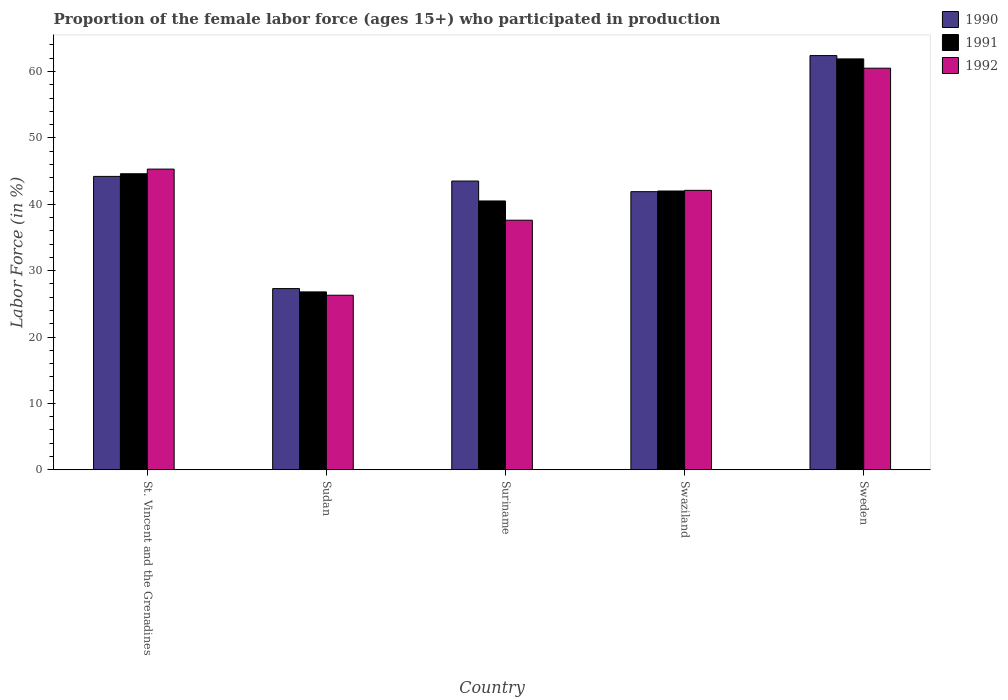How many groups of bars are there?
Provide a succinct answer. 5. Are the number of bars per tick equal to the number of legend labels?
Keep it short and to the point. Yes. How many bars are there on the 2nd tick from the left?
Give a very brief answer. 3. What is the label of the 4th group of bars from the left?
Keep it short and to the point. Swaziland. In how many cases, is the number of bars for a given country not equal to the number of legend labels?
Provide a succinct answer. 0. What is the proportion of the female labor force who participated in production in 1990 in Sudan?
Offer a very short reply. 27.3. Across all countries, what is the maximum proportion of the female labor force who participated in production in 1991?
Keep it short and to the point. 61.9. Across all countries, what is the minimum proportion of the female labor force who participated in production in 1992?
Make the answer very short. 26.3. In which country was the proportion of the female labor force who participated in production in 1991 minimum?
Your response must be concise. Sudan. What is the total proportion of the female labor force who participated in production in 1991 in the graph?
Your answer should be very brief. 215.8. What is the difference between the proportion of the female labor force who participated in production in 1990 in Sudan and that in Suriname?
Keep it short and to the point. -16.2. What is the difference between the proportion of the female labor force who participated in production in 1992 in Sweden and the proportion of the female labor force who participated in production in 1990 in Swaziland?
Provide a succinct answer. 18.6. What is the average proportion of the female labor force who participated in production in 1991 per country?
Keep it short and to the point. 43.16. What is the difference between the proportion of the female labor force who participated in production of/in 1990 and proportion of the female labor force who participated in production of/in 1992 in Swaziland?
Give a very brief answer. -0.2. In how many countries, is the proportion of the female labor force who participated in production in 1990 greater than 52 %?
Provide a short and direct response. 1. What is the ratio of the proportion of the female labor force who participated in production in 1992 in St. Vincent and the Grenadines to that in Sudan?
Provide a succinct answer. 1.72. What is the difference between the highest and the second highest proportion of the female labor force who participated in production in 1991?
Offer a very short reply. -2.6. What is the difference between the highest and the lowest proportion of the female labor force who participated in production in 1992?
Keep it short and to the point. 34.2. In how many countries, is the proportion of the female labor force who participated in production in 1992 greater than the average proportion of the female labor force who participated in production in 1992 taken over all countries?
Make the answer very short. 2. What does the 3rd bar from the left in Swaziland represents?
Offer a terse response. 1992. What does the 1st bar from the right in St. Vincent and the Grenadines represents?
Offer a terse response. 1992. What is the difference between two consecutive major ticks on the Y-axis?
Provide a short and direct response. 10. Are the values on the major ticks of Y-axis written in scientific E-notation?
Keep it short and to the point. No. Does the graph contain any zero values?
Your answer should be compact. No. Does the graph contain grids?
Keep it short and to the point. No. Where does the legend appear in the graph?
Give a very brief answer. Top right. How many legend labels are there?
Give a very brief answer. 3. How are the legend labels stacked?
Ensure brevity in your answer.  Vertical. What is the title of the graph?
Your answer should be very brief. Proportion of the female labor force (ages 15+) who participated in production. What is the Labor Force (in %) of 1990 in St. Vincent and the Grenadines?
Give a very brief answer. 44.2. What is the Labor Force (in %) of 1991 in St. Vincent and the Grenadines?
Provide a succinct answer. 44.6. What is the Labor Force (in %) of 1992 in St. Vincent and the Grenadines?
Keep it short and to the point. 45.3. What is the Labor Force (in %) in 1990 in Sudan?
Your answer should be compact. 27.3. What is the Labor Force (in %) of 1991 in Sudan?
Ensure brevity in your answer.  26.8. What is the Labor Force (in %) in 1992 in Sudan?
Ensure brevity in your answer.  26.3. What is the Labor Force (in %) of 1990 in Suriname?
Ensure brevity in your answer.  43.5. What is the Labor Force (in %) of 1991 in Suriname?
Provide a succinct answer. 40.5. What is the Labor Force (in %) of 1992 in Suriname?
Provide a short and direct response. 37.6. What is the Labor Force (in %) of 1990 in Swaziland?
Your answer should be very brief. 41.9. What is the Labor Force (in %) of 1991 in Swaziland?
Make the answer very short. 42. What is the Labor Force (in %) in 1992 in Swaziland?
Offer a terse response. 42.1. What is the Labor Force (in %) in 1990 in Sweden?
Give a very brief answer. 62.4. What is the Labor Force (in %) of 1991 in Sweden?
Make the answer very short. 61.9. What is the Labor Force (in %) in 1992 in Sweden?
Provide a short and direct response. 60.5. Across all countries, what is the maximum Labor Force (in %) in 1990?
Your answer should be compact. 62.4. Across all countries, what is the maximum Labor Force (in %) of 1991?
Make the answer very short. 61.9. Across all countries, what is the maximum Labor Force (in %) of 1992?
Offer a very short reply. 60.5. Across all countries, what is the minimum Labor Force (in %) of 1990?
Make the answer very short. 27.3. Across all countries, what is the minimum Labor Force (in %) of 1991?
Offer a terse response. 26.8. Across all countries, what is the minimum Labor Force (in %) in 1992?
Provide a succinct answer. 26.3. What is the total Labor Force (in %) in 1990 in the graph?
Ensure brevity in your answer.  219.3. What is the total Labor Force (in %) of 1991 in the graph?
Your response must be concise. 215.8. What is the total Labor Force (in %) of 1992 in the graph?
Keep it short and to the point. 211.8. What is the difference between the Labor Force (in %) of 1990 in St. Vincent and the Grenadines and that in Sudan?
Offer a terse response. 16.9. What is the difference between the Labor Force (in %) in 1991 in St. Vincent and the Grenadines and that in Sudan?
Provide a short and direct response. 17.8. What is the difference between the Labor Force (in %) of 1992 in St. Vincent and the Grenadines and that in Suriname?
Make the answer very short. 7.7. What is the difference between the Labor Force (in %) in 1990 in St. Vincent and the Grenadines and that in Swaziland?
Your answer should be compact. 2.3. What is the difference between the Labor Force (in %) of 1992 in St. Vincent and the Grenadines and that in Swaziland?
Provide a short and direct response. 3.2. What is the difference between the Labor Force (in %) of 1990 in St. Vincent and the Grenadines and that in Sweden?
Provide a succinct answer. -18.2. What is the difference between the Labor Force (in %) of 1991 in St. Vincent and the Grenadines and that in Sweden?
Your response must be concise. -17.3. What is the difference between the Labor Force (in %) of 1992 in St. Vincent and the Grenadines and that in Sweden?
Ensure brevity in your answer.  -15.2. What is the difference between the Labor Force (in %) of 1990 in Sudan and that in Suriname?
Your response must be concise. -16.2. What is the difference between the Labor Force (in %) of 1991 in Sudan and that in Suriname?
Your response must be concise. -13.7. What is the difference between the Labor Force (in %) in 1992 in Sudan and that in Suriname?
Offer a very short reply. -11.3. What is the difference between the Labor Force (in %) of 1990 in Sudan and that in Swaziland?
Give a very brief answer. -14.6. What is the difference between the Labor Force (in %) in 1991 in Sudan and that in Swaziland?
Provide a short and direct response. -15.2. What is the difference between the Labor Force (in %) in 1992 in Sudan and that in Swaziland?
Keep it short and to the point. -15.8. What is the difference between the Labor Force (in %) of 1990 in Sudan and that in Sweden?
Provide a succinct answer. -35.1. What is the difference between the Labor Force (in %) of 1991 in Sudan and that in Sweden?
Ensure brevity in your answer.  -35.1. What is the difference between the Labor Force (in %) of 1992 in Sudan and that in Sweden?
Ensure brevity in your answer.  -34.2. What is the difference between the Labor Force (in %) of 1990 in Suriname and that in Swaziland?
Keep it short and to the point. 1.6. What is the difference between the Labor Force (in %) in 1992 in Suriname and that in Swaziland?
Offer a terse response. -4.5. What is the difference between the Labor Force (in %) of 1990 in Suriname and that in Sweden?
Give a very brief answer. -18.9. What is the difference between the Labor Force (in %) of 1991 in Suriname and that in Sweden?
Give a very brief answer. -21.4. What is the difference between the Labor Force (in %) of 1992 in Suriname and that in Sweden?
Provide a succinct answer. -22.9. What is the difference between the Labor Force (in %) of 1990 in Swaziland and that in Sweden?
Keep it short and to the point. -20.5. What is the difference between the Labor Force (in %) in 1991 in Swaziland and that in Sweden?
Give a very brief answer. -19.9. What is the difference between the Labor Force (in %) in 1992 in Swaziland and that in Sweden?
Your answer should be very brief. -18.4. What is the difference between the Labor Force (in %) in 1990 in St. Vincent and the Grenadines and the Labor Force (in %) in 1991 in Sudan?
Your response must be concise. 17.4. What is the difference between the Labor Force (in %) in 1991 in St. Vincent and the Grenadines and the Labor Force (in %) in 1992 in Sudan?
Keep it short and to the point. 18.3. What is the difference between the Labor Force (in %) of 1990 in St. Vincent and the Grenadines and the Labor Force (in %) of 1992 in Suriname?
Keep it short and to the point. 6.6. What is the difference between the Labor Force (in %) in 1990 in St. Vincent and the Grenadines and the Labor Force (in %) in 1991 in Sweden?
Your response must be concise. -17.7. What is the difference between the Labor Force (in %) in 1990 in St. Vincent and the Grenadines and the Labor Force (in %) in 1992 in Sweden?
Your answer should be very brief. -16.3. What is the difference between the Labor Force (in %) of 1991 in St. Vincent and the Grenadines and the Labor Force (in %) of 1992 in Sweden?
Ensure brevity in your answer.  -15.9. What is the difference between the Labor Force (in %) in 1990 in Sudan and the Labor Force (in %) in 1991 in Suriname?
Your answer should be compact. -13.2. What is the difference between the Labor Force (in %) of 1990 in Sudan and the Labor Force (in %) of 1992 in Suriname?
Provide a succinct answer. -10.3. What is the difference between the Labor Force (in %) of 1990 in Sudan and the Labor Force (in %) of 1991 in Swaziland?
Offer a very short reply. -14.7. What is the difference between the Labor Force (in %) in 1990 in Sudan and the Labor Force (in %) in 1992 in Swaziland?
Ensure brevity in your answer.  -14.8. What is the difference between the Labor Force (in %) in 1991 in Sudan and the Labor Force (in %) in 1992 in Swaziland?
Your answer should be very brief. -15.3. What is the difference between the Labor Force (in %) of 1990 in Sudan and the Labor Force (in %) of 1991 in Sweden?
Give a very brief answer. -34.6. What is the difference between the Labor Force (in %) of 1990 in Sudan and the Labor Force (in %) of 1992 in Sweden?
Provide a succinct answer. -33.2. What is the difference between the Labor Force (in %) of 1991 in Sudan and the Labor Force (in %) of 1992 in Sweden?
Provide a succinct answer. -33.7. What is the difference between the Labor Force (in %) in 1991 in Suriname and the Labor Force (in %) in 1992 in Swaziland?
Provide a succinct answer. -1.6. What is the difference between the Labor Force (in %) in 1990 in Suriname and the Labor Force (in %) in 1991 in Sweden?
Offer a terse response. -18.4. What is the difference between the Labor Force (in %) in 1990 in Suriname and the Labor Force (in %) in 1992 in Sweden?
Make the answer very short. -17. What is the difference between the Labor Force (in %) of 1991 in Suriname and the Labor Force (in %) of 1992 in Sweden?
Make the answer very short. -20. What is the difference between the Labor Force (in %) in 1990 in Swaziland and the Labor Force (in %) in 1991 in Sweden?
Provide a succinct answer. -20. What is the difference between the Labor Force (in %) of 1990 in Swaziland and the Labor Force (in %) of 1992 in Sweden?
Provide a succinct answer. -18.6. What is the difference between the Labor Force (in %) of 1991 in Swaziland and the Labor Force (in %) of 1992 in Sweden?
Your response must be concise. -18.5. What is the average Labor Force (in %) in 1990 per country?
Your answer should be very brief. 43.86. What is the average Labor Force (in %) of 1991 per country?
Offer a terse response. 43.16. What is the average Labor Force (in %) of 1992 per country?
Give a very brief answer. 42.36. What is the difference between the Labor Force (in %) of 1990 and Labor Force (in %) of 1991 in St. Vincent and the Grenadines?
Provide a short and direct response. -0.4. What is the difference between the Labor Force (in %) in 1990 and Labor Force (in %) in 1991 in Sudan?
Offer a very short reply. 0.5. What is the difference between the Labor Force (in %) of 1990 and Labor Force (in %) of 1992 in Sudan?
Ensure brevity in your answer.  1. What is the difference between the Labor Force (in %) in 1991 and Labor Force (in %) in 1992 in Sudan?
Your response must be concise. 0.5. What is the difference between the Labor Force (in %) in 1990 and Labor Force (in %) in 1991 in Suriname?
Offer a terse response. 3. What is the difference between the Labor Force (in %) in 1991 and Labor Force (in %) in 1992 in Suriname?
Keep it short and to the point. 2.9. What is the difference between the Labor Force (in %) in 1990 and Labor Force (in %) in 1992 in Swaziland?
Offer a terse response. -0.2. What is the difference between the Labor Force (in %) in 1991 and Labor Force (in %) in 1992 in Swaziland?
Give a very brief answer. -0.1. What is the difference between the Labor Force (in %) of 1991 and Labor Force (in %) of 1992 in Sweden?
Offer a very short reply. 1.4. What is the ratio of the Labor Force (in %) of 1990 in St. Vincent and the Grenadines to that in Sudan?
Your response must be concise. 1.62. What is the ratio of the Labor Force (in %) in 1991 in St. Vincent and the Grenadines to that in Sudan?
Your answer should be very brief. 1.66. What is the ratio of the Labor Force (in %) of 1992 in St. Vincent and the Grenadines to that in Sudan?
Your answer should be compact. 1.72. What is the ratio of the Labor Force (in %) of 1990 in St. Vincent and the Grenadines to that in Suriname?
Ensure brevity in your answer.  1.02. What is the ratio of the Labor Force (in %) in 1991 in St. Vincent and the Grenadines to that in Suriname?
Your answer should be compact. 1.1. What is the ratio of the Labor Force (in %) of 1992 in St. Vincent and the Grenadines to that in Suriname?
Provide a short and direct response. 1.2. What is the ratio of the Labor Force (in %) in 1990 in St. Vincent and the Grenadines to that in Swaziland?
Give a very brief answer. 1.05. What is the ratio of the Labor Force (in %) of 1991 in St. Vincent and the Grenadines to that in Swaziland?
Provide a succinct answer. 1.06. What is the ratio of the Labor Force (in %) in 1992 in St. Vincent and the Grenadines to that in Swaziland?
Provide a succinct answer. 1.08. What is the ratio of the Labor Force (in %) in 1990 in St. Vincent and the Grenadines to that in Sweden?
Ensure brevity in your answer.  0.71. What is the ratio of the Labor Force (in %) in 1991 in St. Vincent and the Grenadines to that in Sweden?
Offer a terse response. 0.72. What is the ratio of the Labor Force (in %) of 1992 in St. Vincent and the Grenadines to that in Sweden?
Provide a short and direct response. 0.75. What is the ratio of the Labor Force (in %) in 1990 in Sudan to that in Suriname?
Ensure brevity in your answer.  0.63. What is the ratio of the Labor Force (in %) of 1991 in Sudan to that in Suriname?
Provide a short and direct response. 0.66. What is the ratio of the Labor Force (in %) in 1992 in Sudan to that in Suriname?
Offer a very short reply. 0.7. What is the ratio of the Labor Force (in %) in 1990 in Sudan to that in Swaziland?
Keep it short and to the point. 0.65. What is the ratio of the Labor Force (in %) in 1991 in Sudan to that in Swaziland?
Your response must be concise. 0.64. What is the ratio of the Labor Force (in %) of 1992 in Sudan to that in Swaziland?
Provide a short and direct response. 0.62. What is the ratio of the Labor Force (in %) in 1990 in Sudan to that in Sweden?
Offer a very short reply. 0.44. What is the ratio of the Labor Force (in %) in 1991 in Sudan to that in Sweden?
Your response must be concise. 0.43. What is the ratio of the Labor Force (in %) of 1992 in Sudan to that in Sweden?
Offer a terse response. 0.43. What is the ratio of the Labor Force (in %) in 1990 in Suriname to that in Swaziland?
Make the answer very short. 1.04. What is the ratio of the Labor Force (in %) in 1992 in Suriname to that in Swaziland?
Keep it short and to the point. 0.89. What is the ratio of the Labor Force (in %) in 1990 in Suriname to that in Sweden?
Offer a terse response. 0.7. What is the ratio of the Labor Force (in %) of 1991 in Suriname to that in Sweden?
Your answer should be very brief. 0.65. What is the ratio of the Labor Force (in %) in 1992 in Suriname to that in Sweden?
Give a very brief answer. 0.62. What is the ratio of the Labor Force (in %) in 1990 in Swaziland to that in Sweden?
Offer a very short reply. 0.67. What is the ratio of the Labor Force (in %) in 1991 in Swaziland to that in Sweden?
Keep it short and to the point. 0.68. What is the ratio of the Labor Force (in %) of 1992 in Swaziland to that in Sweden?
Your answer should be compact. 0.7. What is the difference between the highest and the second highest Labor Force (in %) in 1990?
Your response must be concise. 18.2. What is the difference between the highest and the second highest Labor Force (in %) in 1991?
Ensure brevity in your answer.  17.3. What is the difference between the highest and the second highest Labor Force (in %) in 1992?
Provide a short and direct response. 15.2. What is the difference between the highest and the lowest Labor Force (in %) in 1990?
Your answer should be compact. 35.1. What is the difference between the highest and the lowest Labor Force (in %) in 1991?
Your answer should be compact. 35.1. What is the difference between the highest and the lowest Labor Force (in %) in 1992?
Make the answer very short. 34.2. 